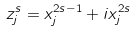<formula> <loc_0><loc_0><loc_500><loc_500>z _ { j } ^ { s } = x _ { j } ^ { 2 s - 1 } + i x _ { j } ^ { 2 s }</formula> 